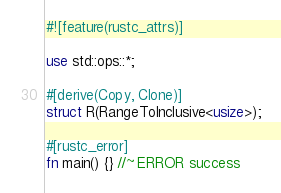Convert code to text. <code><loc_0><loc_0><loc_500><loc_500><_Rust_>
#![feature(rustc_attrs)]

use std::ops::*;

#[derive(Copy, Clone)]
struct R(RangeToInclusive<usize>);

#[rustc_error]
fn main() {} //~ ERROR success

</code> 